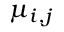<formula> <loc_0><loc_0><loc_500><loc_500>\mu _ { i , j }</formula> 